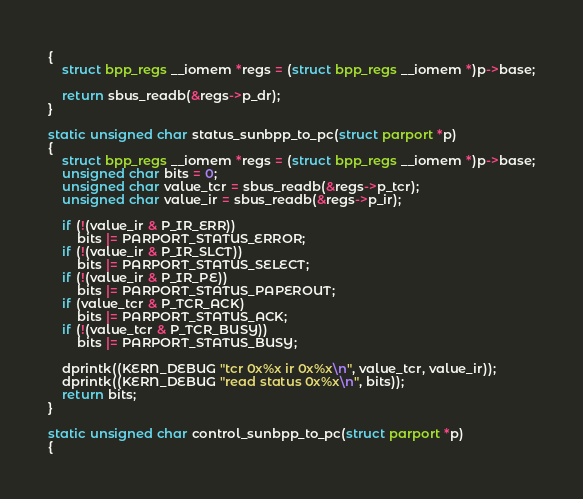Convert code to text. <code><loc_0><loc_0><loc_500><loc_500><_C_>{
	struct bpp_regs __iomem *regs = (struct bpp_regs __iomem *)p->base;

	return sbus_readb(&regs->p_dr);
}

static unsigned char status_sunbpp_to_pc(struct parport *p)
{
	struct bpp_regs __iomem *regs = (struct bpp_regs __iomem *)p->base;
	unsigned char bits = 0;
	unsigned char value_tcr = sbus_readb(&regs->p_tcr);
	unsigned char value_ir = sbus_readb(&regs->p_ir);

	if (!(value_ir & P_IR_ERR))
		bits |= PARPORT_STATUS_ERROR;
	if (!(value_ir & P_IR_SLCT))
		bits |= PARPORT_STATUS_SELECT;
	if (!(value_ir & P_IR_PE))
		bits |= PARPORT_STATUS_PAPEROUT;
	if (value_tcr & P_TCR_ACK)
		bits |= PARPORT_STATUS_ACK;
	if (!(value_tcr & P_TCR_BUSY))
		bits |= PARPORT_STATUS_BUSY;

	dprintk((KERN_DEBUG "tcr 0x%x ir 0x%x\n", value_tcr, value_ir));
	dprintk((KERN_DEBUG "read status 0x%x\n", bits));
	return bits;
}

static unsigned char control_sunbpp_to_pc(struct parport *p)
{</code> 